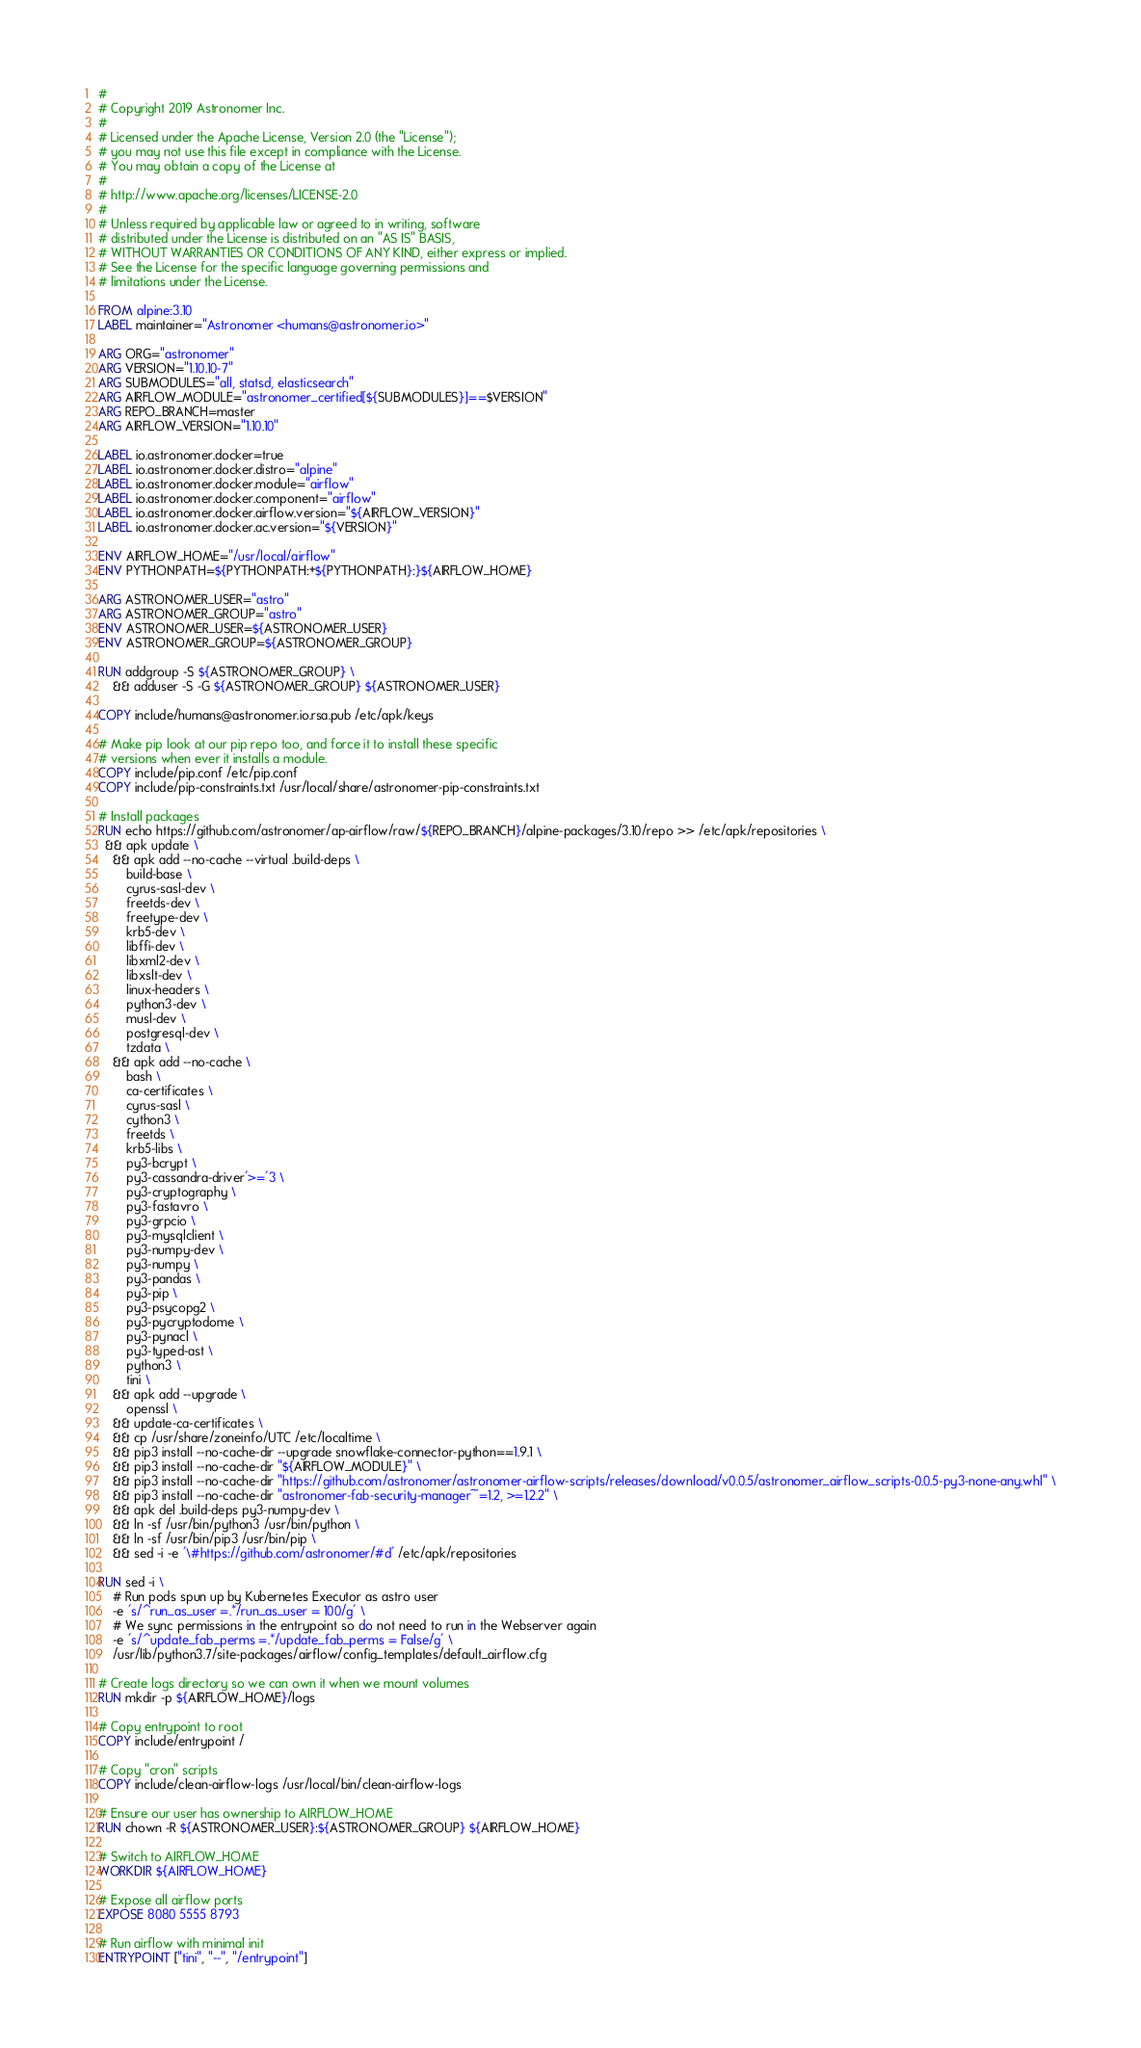Convert code to text. <code><loc_0><loc_0><loc_500><loc_500><_Dockerfile_>#
# Copyright 2019 Astronomer Inc.
#
# Licensed under the Apache License, Version 2.0 (the "License");
# you may not use this file except in compliance with the License.
# You may obtain a copy of the License at
#
# http://www.apache.org/licenses/LICENSE-2.0
#
# Unless required by applicable law or agreed to in writing, software
# distributed under the License is distributed on an "AS IS" BASIS,
# WITHOUT WARRANTIES OR CONDITIONS OF ANY KIND, either express or implied.
# See the License for the specific language governing permissions and
# limitations under the License.

FROM alpine:3.10
LABEL maintainer="Astronomer <humans@astronomer.io>"

ARG ORG="astronomer"
ARG VERSION="1.10.10-7"
ARG SUBMODULES="all, statsd, elasticsearch"
ARG AIRFLOW_MODULE="astronomer_certified[${SUBMODULES}]==$VERSION"
ARG REPO_BRANCH=master
ARG AIRFLOW_VERSION="1.10.10"

LABEL io.astronomer.docker=true
LABEL io.astronomer.docker.distro="alpine"
LABEL io.astronomer.docker.module="airflow"
LABEL io.astronomer.docker.component="airflow"
LABEL io.astronomer.docker.airflow.version="${AIRFLOW_VERSION}"
LABEL io.astronomer.docker.ac.version="${VERSION}"

ENV AIRFLOW_HOME="/usr/local/airflow"
ENV PYTHONPATH=${PYTHONPATH:+${PYTHONPATH}:}${AIRFLOW_HOME}

ARG ASTRONOMER_USER="astro"
ARG ASTRONOMER_GROUP="astro"
ENV ASTRONOMER_USER=${ASTRONOMER_USER}
ENV ASTRONOMER_GROUP=${ASTRONOMER_GROUP}

RUN addgroup -S ${ASTRONOMER_GROUP} \
	&& adduser -S -G ${ASTRONOMER_GROUP} ${ASTRONOMER_USER}

COPY include/humans@astronomer.io.rsa.pub /etc/apk/keys

# Make pip look at our pip repo too, and force it to install these specific
# versions when ever it installs a module.
COPY include/pip.conf /etc/pip.conf
COPY include/pip-constraints.txt /usr/local/share/astronomer-pip-constraints.txt

# Install packages
RUN echo https://github.com/astronomer/ap-airflow/raw/${REPO_BRANCH}/alpine-packages/3.10/repo >> /etc/apk/repositories \
  && apk update \
	&& apk add --no-cache --virtual .build-deps \
		build-base \
		cyrus-sasl-dev \
		freetds-dev \
		freetype-dev \
		krb5-dev \
		libffi-dev \
		libxml2-dev \
		libxslt-dev \
		linux-headers \
		python3-dev \
		musl-dev \
		postgresql-dev \
		tzdata \
	&& apk add --no-cache \
		bash \
		ca-certificates \
		cyrus-sasl \
		cython3 \
		freetds \
		krb5-libs \
		py3-bcrypt \
		py3-cassandra-driver'>='3 \
		py3-cryptography \
		py3-fastavro \
		py3-grpcio \
		py3-mysqlclient \
		py3-numpy-dev \
		py3-numpy \
		py3-pandas \
		py3-pip \
		py3-psycopg2 \
		py3-pycryptodome \
		py3-pynacl \
		py3-typed-ast \
		python3 \
		tini \
	&& apk add --upgrade \
		openssl \
	&& update-ca-certificates \
	&& cp /usr/share/zoneinfo/UTC /etc/localtime \
	&& pip3 install --no-cache-dir --upgrade snowflake-connector-python==1.9.1 \
	&& pip3 install --no-cache-dir "${AIRFLOW_MODULE}" \
	&& pip3 install --no-cache-dir "https://github.com/astronomer/astronomer-airflow-scripts/releases/download/v0.0.5/astronomer_airflow_scripts-0.0.5-py3-none-any.whl" \
	&& pip3 install --no-cache-dir "astronomer-fab-security-manager~=1.2, >=1.2.2" \
	&& apk del .build-deps py3-numpy-dev \
	&& ln -sf /usr/bin/python3 /usr/bin/python \
	&& ln -sf /usr/bin/pip3 /usr/bin/pip \
	&& sed -i -e '\#https://github.com/astronomer/#d' /etc/apk/repositories

RUN sed -i \
    # Run pods spun up by Kubernetes Executor as astro user
    -e 's/^run_as_user =.*/run_as_user = 100/g' \
    # We sync permissions in the entrypoint so do not need to run in the Webserver again
    -e 's/^update_fab_perms =.*/update_fab_perms = False/g' \
    /usr/lib/python3.7/site-packages/airflow/config_templates/default_airflow.cfg

# Create logs directory so we can own it when we mount volumes
RUN mkdir -p ${AIRFLOW_HOME}/logs

# Copy entrypoint to root
COPY include/entrypoint /

# Copy "cron" scripts
COPY include/clean-airflow-logs /usr/local/bin/clean-airflow-logs

# Ensure our user has ownership to AIRFLOW_HOME
RUN chown -R ${ASTRONOMER_USER}:${ASTRONOMER_GROUP} ${AIRFLOW_HOME}

# Switch to AIRFLOW_HOME
WORKDIR ${AIRFLOW_HOME}

# Expose all airflow ports
EXPOSE 8080 5555 8793

# Run airflow with minimal init
ENTRYPOINT ["tini", "--", "/entrypoint"]
</code> 